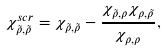Convert formula to latex. <formula><loc_0><loc_0><loc_500><loc_500>\chi _ { \tilde { \rho } , \tilde { \rho } } ^ { s c r } = \chi _ { \tilde { \rho } , \tilde { \rho } } - \frac { \chi _ { \tilde { \rho } , \rho } \chi _ { \rho , \tilde { \rho } } } { \chi _ { \rho , \rho } } ,</formula> 